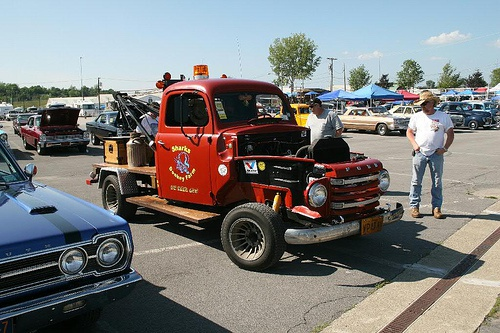Describe the objects in this image and their specific colors. I can see truck in lightblue, black, brown, gray, and maroon tones, car in lightblue, black, and gray tones, people in lightblue, white, darkgray, gray, and blue tones, car in lightblue, black, gray, maroon, and darkgray tones, and car in lightblue, ivory, gray, darkgray, and black tones in this image. 